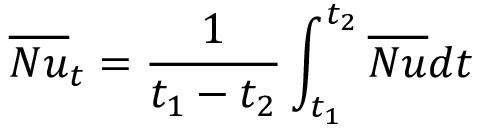<formula> <loc_0><loc_0><loc_500><loc_500>\overline { N u } _ { t } = \frac { 1 } { t _ { 1 } - t _ { 2 } } \int _ { t _ { 1 } } ^ { t _ { 2 } } \overline { N u } d t</formula> 